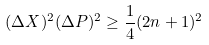Convert formula to latex. <formula><loc_0><loc_0><loc_500><loc_500>( \Delta X ) ^ { 2 } ( \Delta P ) ^ { 2 } \geq \frac { 1 } { 4 } ( 2 n + 1 ) ^ { 2 }</formula> 